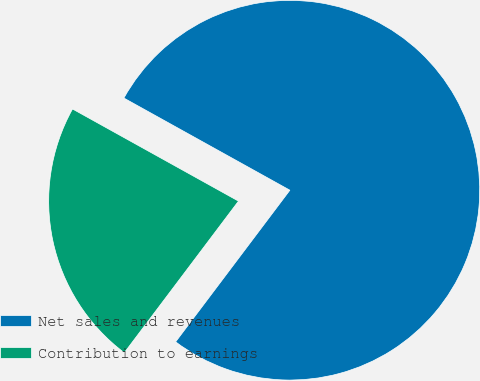<chart> <loc_0><loc_0><loc_500><loc_500><pie_chart><fcel>Net sales and revenues<fcel>Contribution to earnings<nl><fcel>77.21%<fcel>22.79%<nl></chart> 